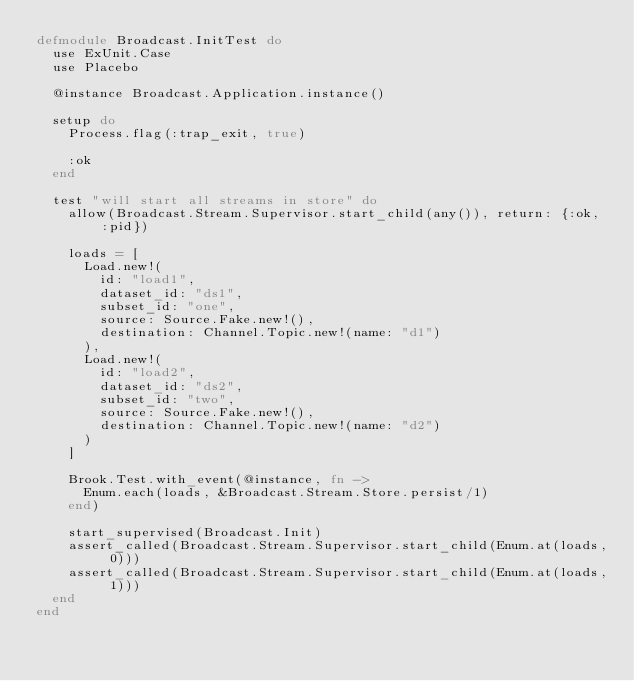Convert code to text. <code><loc_0><loc_0><loc_500><loc_500><_Elixir_>defmodule Broadcast.InitTest do
  use ExUnit.Case
  use Placebo

  @instance Broadcast.Application.instance()

  setup do
    Process.flag(:trap_exit, true)

    :ok
  end

  test "will start all streams in store" do
    allow(Broadcast.Stream.Supervisor.start_child(any()), return: {:ok, :pid})

    loads = [
      Load.new!(
        id: "load1",
        dataset_id: "ds1",
        subset_id: "one",
        source: Source.Fake.new!(),
        destination: Channel.Topic.new!(name: "d1")
      ),
      Load.new!(
        id: "load2",
        dataset_id: "ds2",
        subset_id: "two",
        source: Source.Fake.new!(),
        destination: Channel.Topic.new!(name: "d2")
      )
    ]

    Brook.Test.with_event(@instance, fn ->
      Enum.each(loads, &Broadcast.Stream.Store.persist/1)
    end)

    start_supervised(Broadcast.Init)
    assert_called(Broadcast.Stream.Supervisor.start_child(Enum.at(loads, 0)))
    assert_called(Broadcast.Stream.Supervisor.start_child(Enum.at(loads, 1)))
  end
end
</code> 